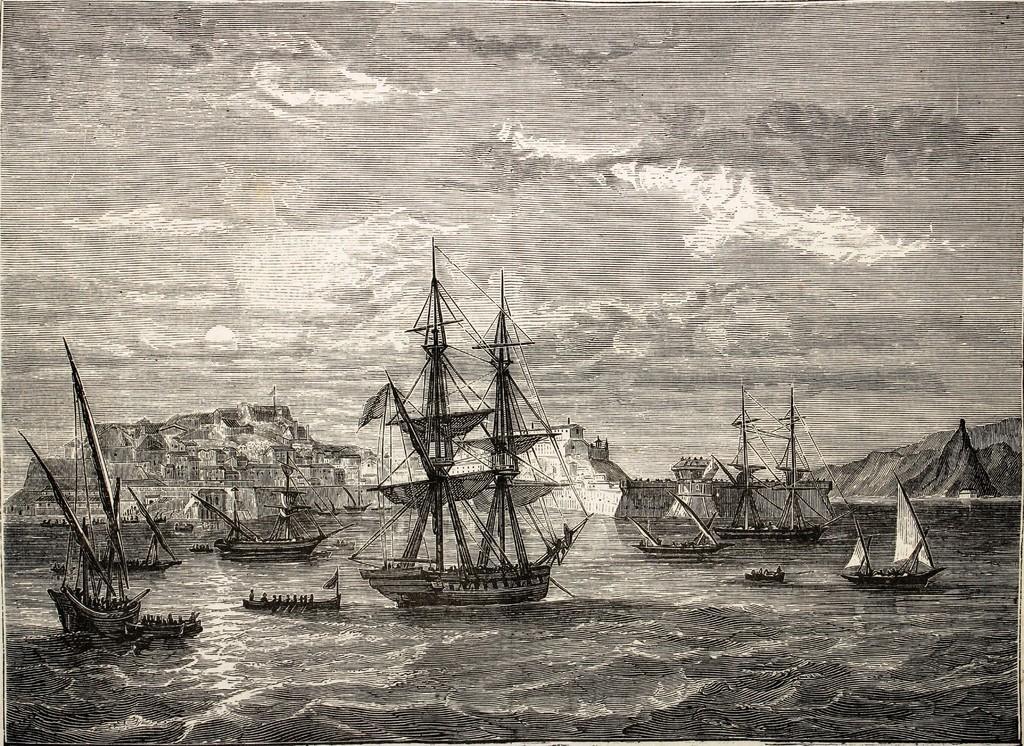How would you summarize this image in a sentence or two? In the picture we can see a sketch drawing of a water and some boats on it and behind it, we can see a hill with houses and in the background we can see a sky with clouds. 